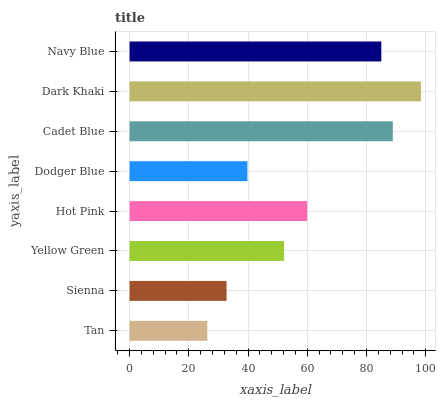Is Tan the minimum?
Answer yes or no. Yes. Is Dark Khaki the maximum?
Answer yes or no. Yes. Is Sienna the minimum?
Answer yes or no. No. Is Sienna the maximum?
Answer yes or no. No. Is Sienna greater than Tan?
Answer yes or no. Yes. Is Tan less than Sienna?
Answer yes or no. Yes. Is Tan greater than Sienna?
Answer yes or no. No. Is Sienna less than Tan?
Answer yes or no. No. Is Hot Pink the high median?
Answer yes or no. Yes. Is Yellow Green the low median?
Answer yes or no. Yes. Is Sienna the high median?
Answer yes or no. No. Is Dodger Blue the low median?
Answer yes or no. No. 